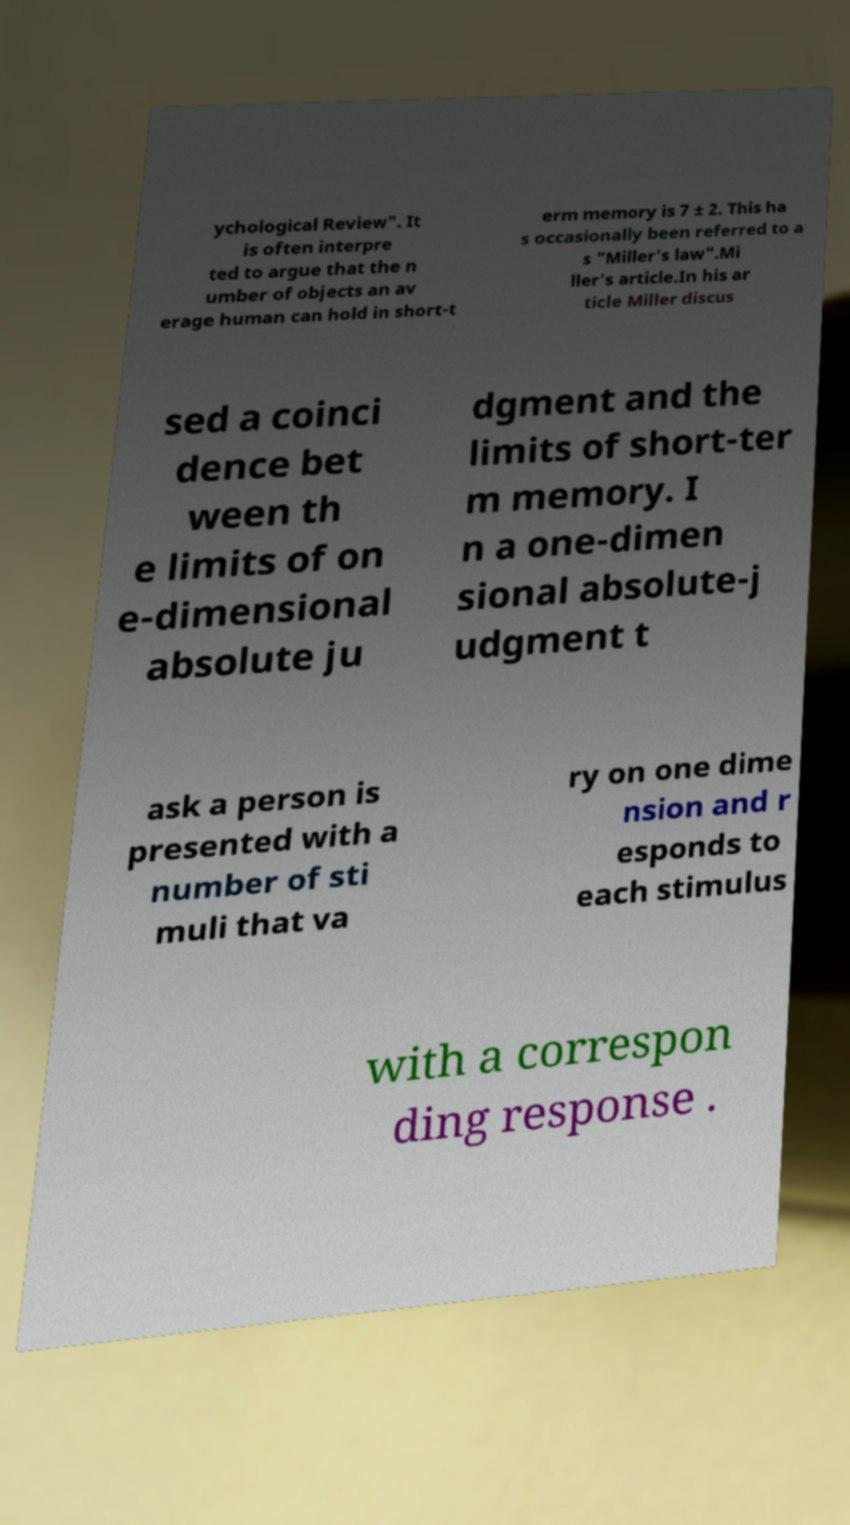There's text embedded in this image that I need extracted. Can you transcribe it verbatim? ychological Review". It is often interpre ted to argue that the n umber of objects an av erage human can hold in short-t erm memory is 7 ± 2. This ha s occasionally been referred to a s "Miller's law".Mi ller's article.In his ar ticle Miller discus sed a coinci dence bet ween th e limits of on e-dimensional absolute ju dgment and the limits of short-ter m memory. I n a one-dimen sional absolute-j udgment t ask a person is presented with a number of sti muli that va ry on one dime nsion and r esponds to each stimulus with a correspon ding response . 